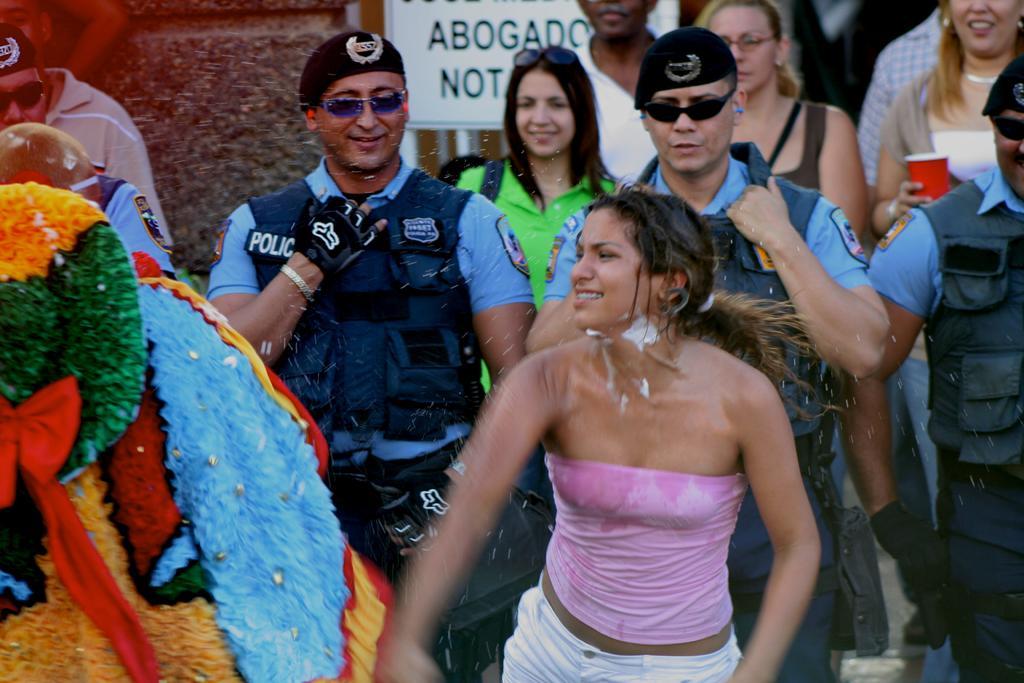Can you describe this image briefly? In front of the picture, we see a woman in the pink T-shirt is standing and she is smiling. Behind her, we see three men in the uniform are standing and they are smiling. Behind them, we see the people are standing. The woman on the right side is holding a glass in her hand. On the left side, we see a blanket or a cloth in yellow, green, blue and red color. In the background, we see a board in white color with some text written on it. 